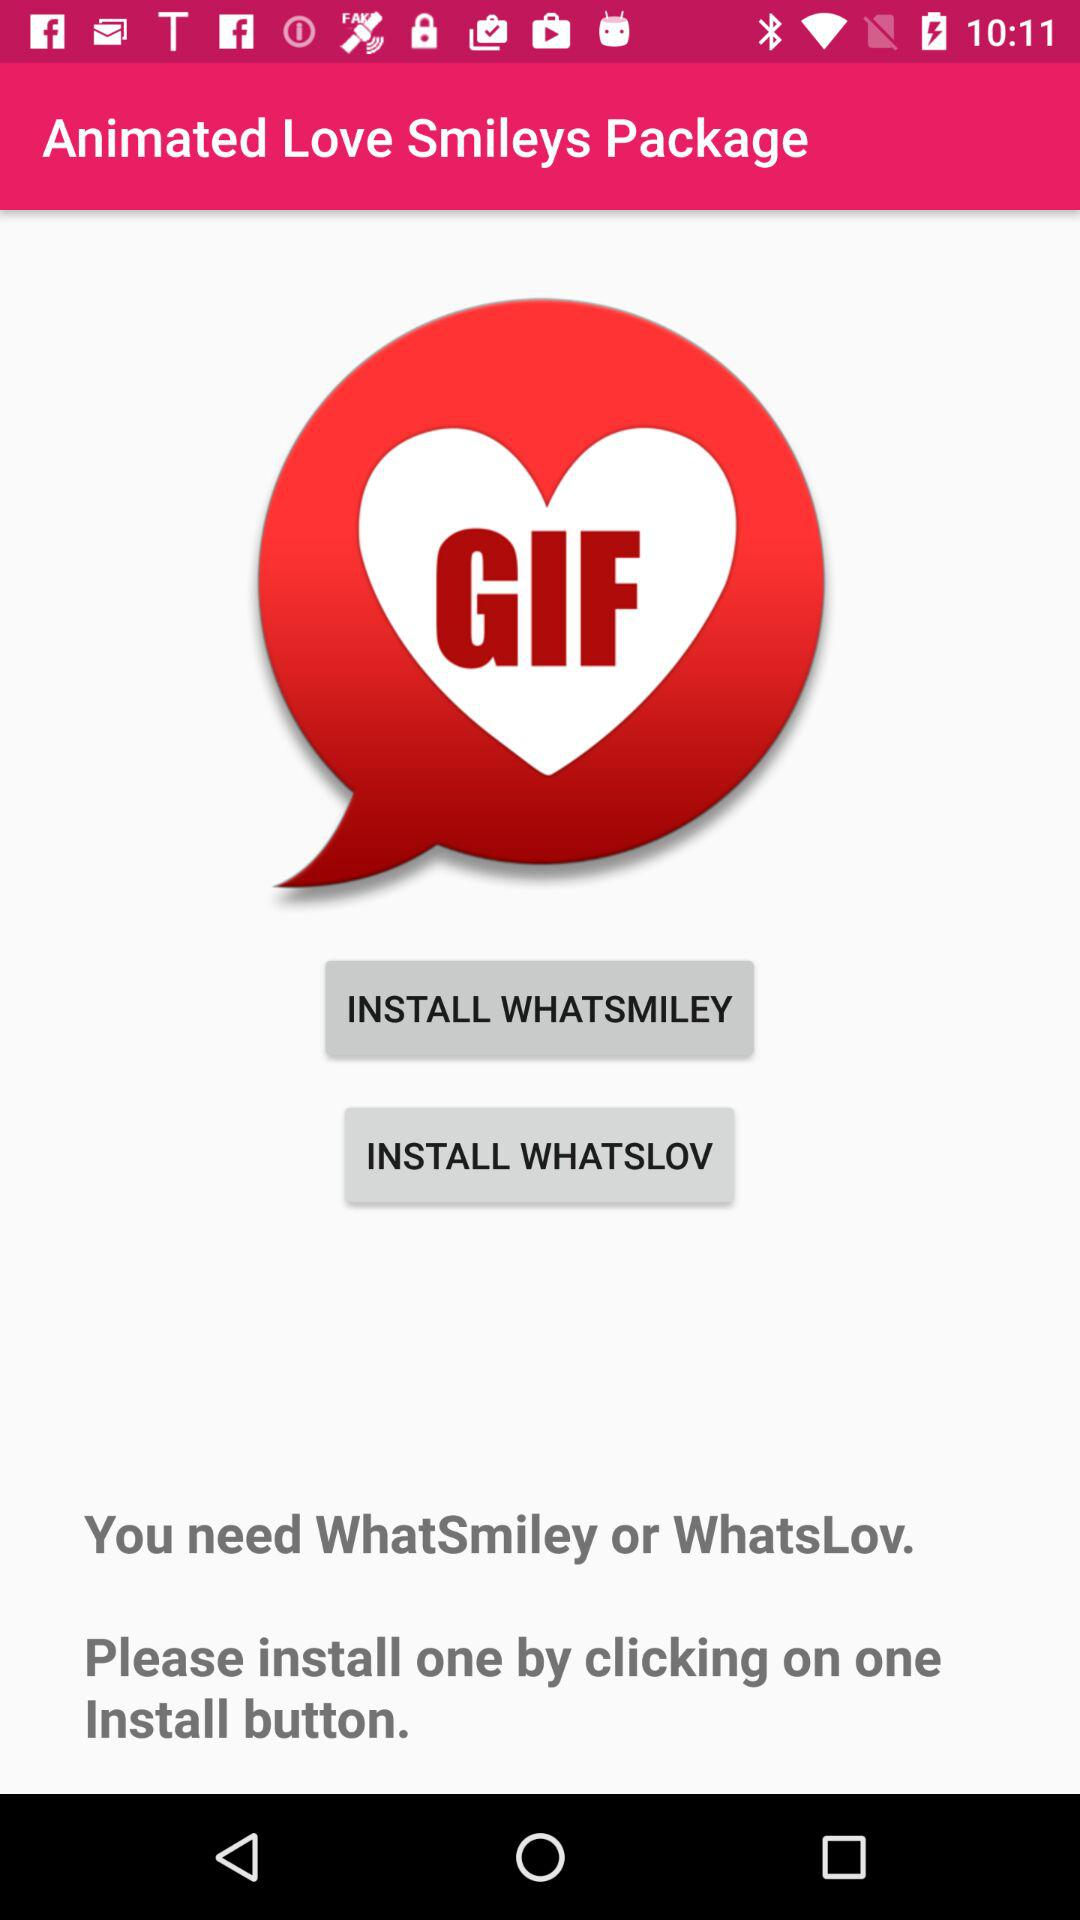What are the different applications available for installing? The different applications available for installing are "WHATSMILEY" and "WHATSLOV". 